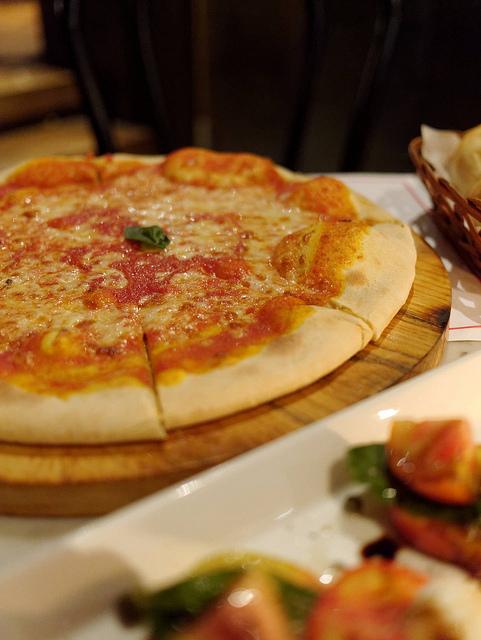What is the pizza sitting on?
Concise answer only. Cutting board. Is this pizza?
Short answer required. Yes. What is the pizza pan made of?
Be succinct. Wood. Where was the picture taken?
Be succinct. Restaurant. 